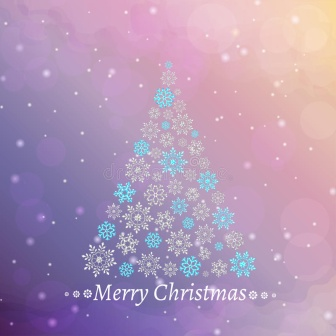Imagine you are inside this scene. What sounds and smells might you experience? If you were inside this enchanting Christmas scene, you might hear the soft sound of snow gently falling to the ground, perhaps accompanied by the distant murmur of cheerful holiday tunes. The air would be crisp and filled with the delightful scents of fresh pine, mingled with hints of cinnamon and cloves from baked holiday treats. The serenity of the scene might be occasionally punctuated by the laughter of loved ones sharing in the festive joy. How might this scene look at different times of the day? In the morning, the scene would be bathed in the soft, golden light of dawn, making the snowflakes glisten like tiny gems. By noon, the bright sunlight would enhance the vibrant colors of the background, creating a more lively and cheerful atmosphere. Come evening, the sky would adopt a deeper, more muted palette, with the tree illuminated by gentle fairy lights, adding a magical glow to the entire scene. At night, under the starlit sky, the scene would take on a serene and tranquil tone, with the snowflakes reflecting the soft moonlight, creating a dreamy and almost ethereal ambiance. 